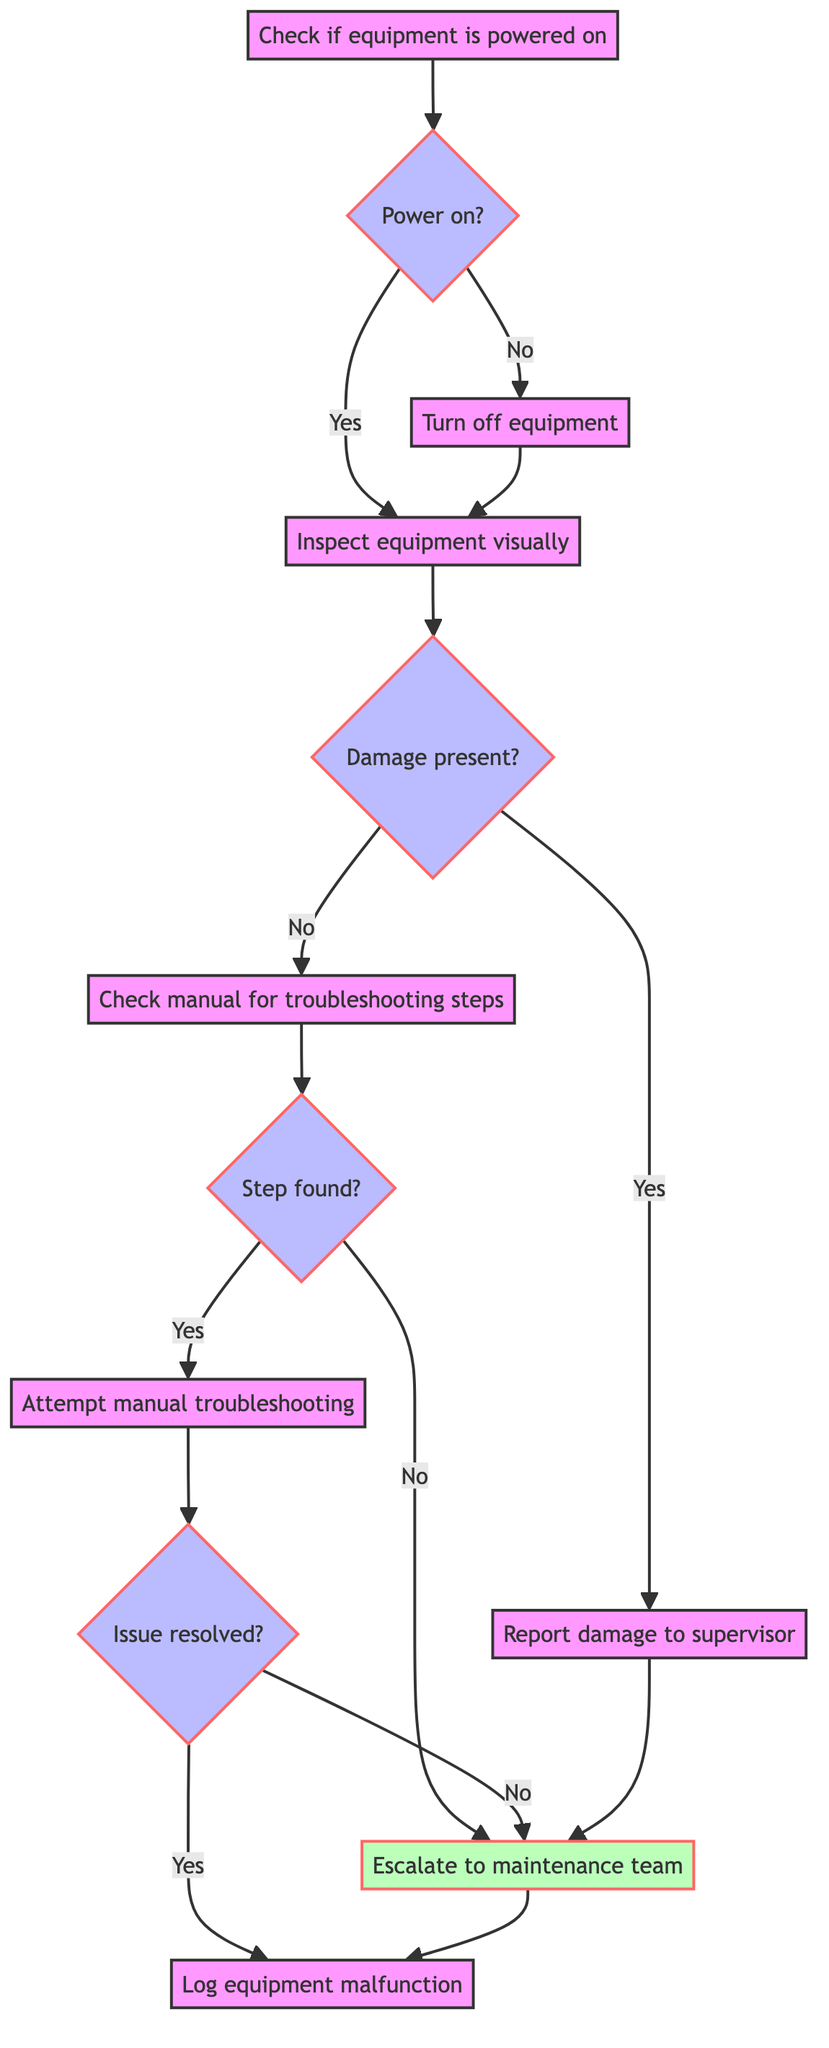What is the first step in the flowchart? The first step in the flowchart is "Check if the equipment is powered on." This is the starting action that initiates the process of handling equipment malfunctions.
Answer: Check if the equipment is powered on What action follows after "Turn off equipment"? After the action "Turn off equipment," the next action is "Inspect equipment visually." This follows the step where the machine is powered down safely.
Answer: Inspect equipment visually How many decision points are there in the flowchart? The flowchart contains four decision points: Power on?, Damage present?, Step found?, and Issue resolved?. Each of these asks a yes/no question that determines the next action.
Answer: Four What happens if the equipment is not powered on? If the equipment is not powered on, the flowchart dictates that the next action is to "Turn off equipment." After powering down safely, it proceeds to inspect the equipment visually.
Answer: Turn off equipment What is the output if damage is present? If damage is present, the output directs to "Report damage to supervisor." This indicates that visible damage requires notifying the supervisor for further instructions.
Answer: Report damage to supervisor What are the two possible outcomes after attempting manual troubleshooting? After attempting manual troubleshooting, the two possible outcomes are "Issue resolved" or "Issue not resolved." Depending on the result, the process will either log the malfunction or escalate to the maintenance team.
Answer: Issue resolved, Issue not resolved What is the final action in the flowchart? The final action in the flowchart is "Log equipment malfunction." This step completes the process by documenting the malfunction and the actions taken.
Answer: Log equipment malfunction What action occurs if no troubleshooting steps are found? If no troubleshooting steps are found, the flowchart directs to "Escalate to maintenance team." This action is taken when manual troubleshooting is not an option.
Answer: Escalate to maintenance team What type of action is "Inspect equipment visually"? "Inspect equipment visually" is a basic action in the flowchart indicating that the worker should look for obvious physical issues. It requires no yes/no decision but rather an assessment.
Answer: Action 